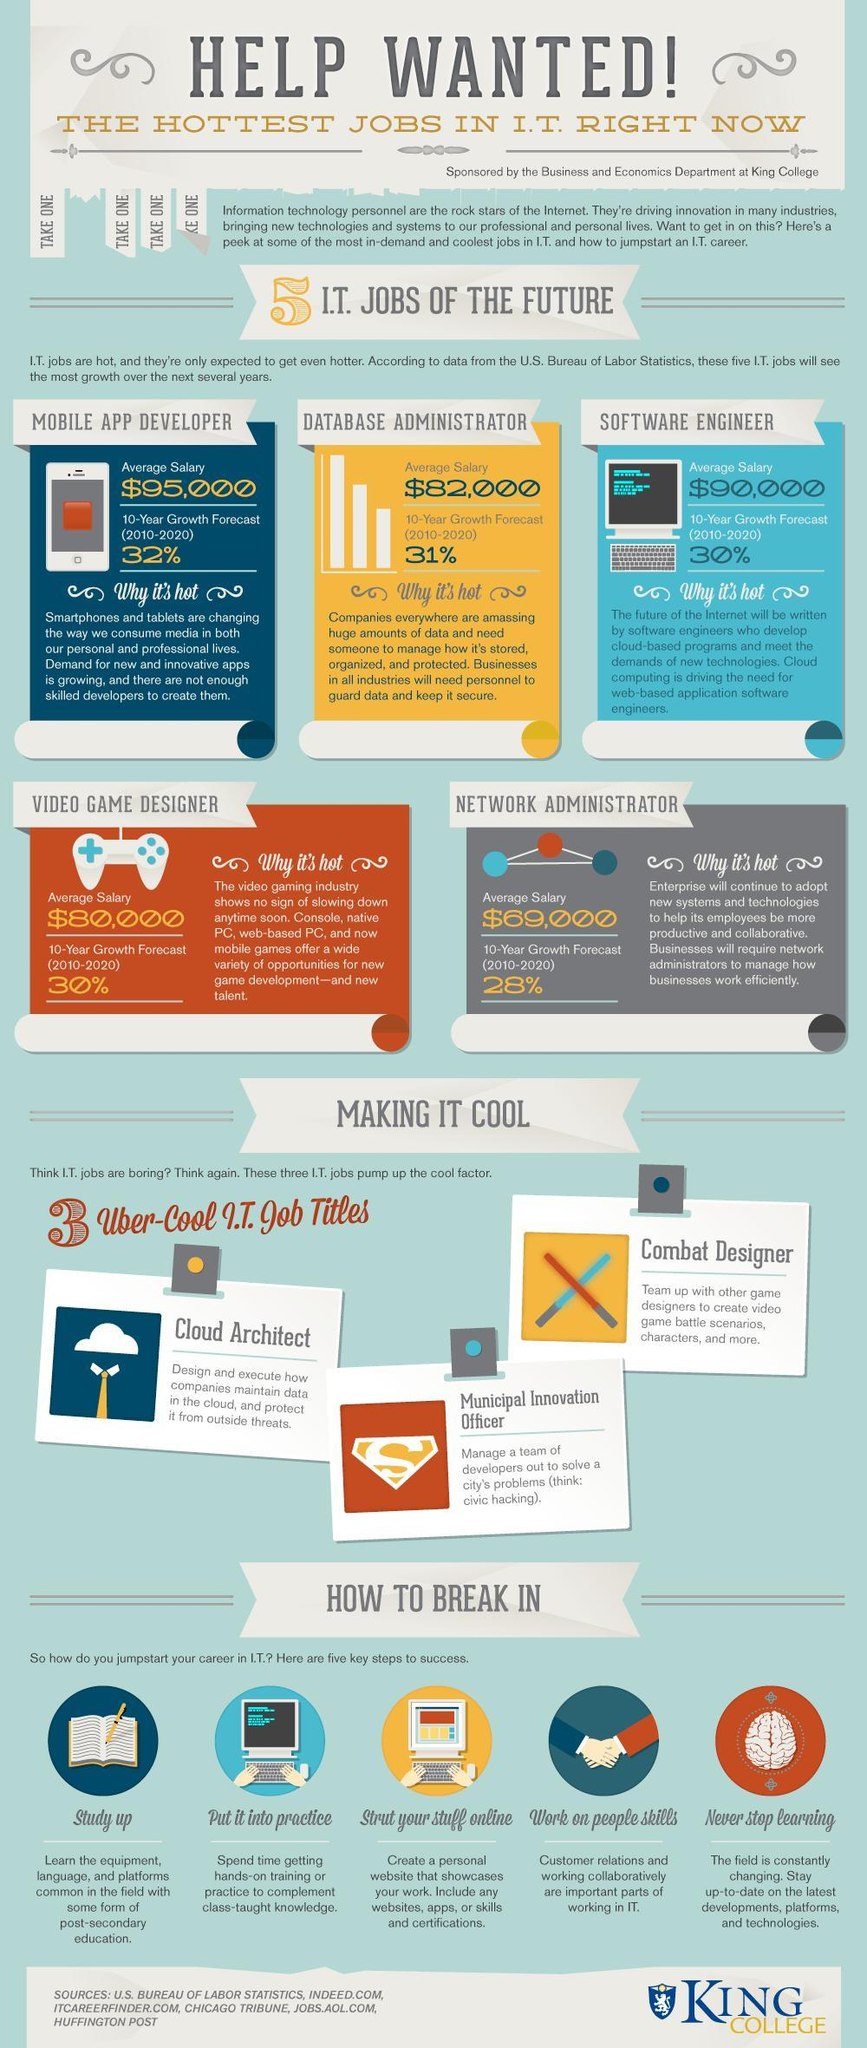Which IT job has average salary less than $80,000?
Answer the question with a short phrase. NETWORK ADMINISTRATOR Which title involves maintenance of data? Cloud Architect Which IT job has the most predicted 10 year growth rate? MOBILE APP DEVELOPER 